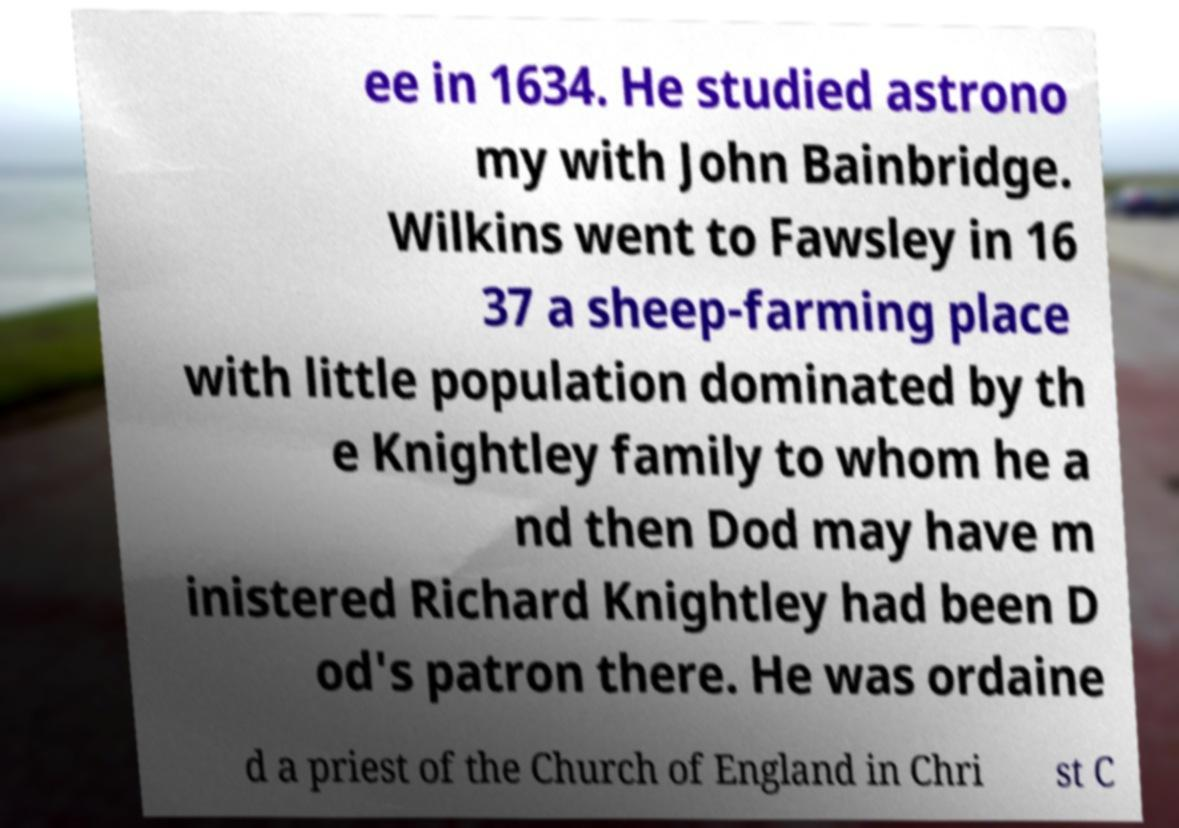I need the written content from this picture converted into text. Can you do that? ee in 1634. He studied astrono my with John Bainbridge. Wilkins went to Fawsley in 16 37 a sheep-farming place with little population dominated by th e Knightley family to whom he a nd then Dod may have m inistered Richard Knightley had been D od's patron there. He was ordaine d a priest of the Church of England in Chri st C 